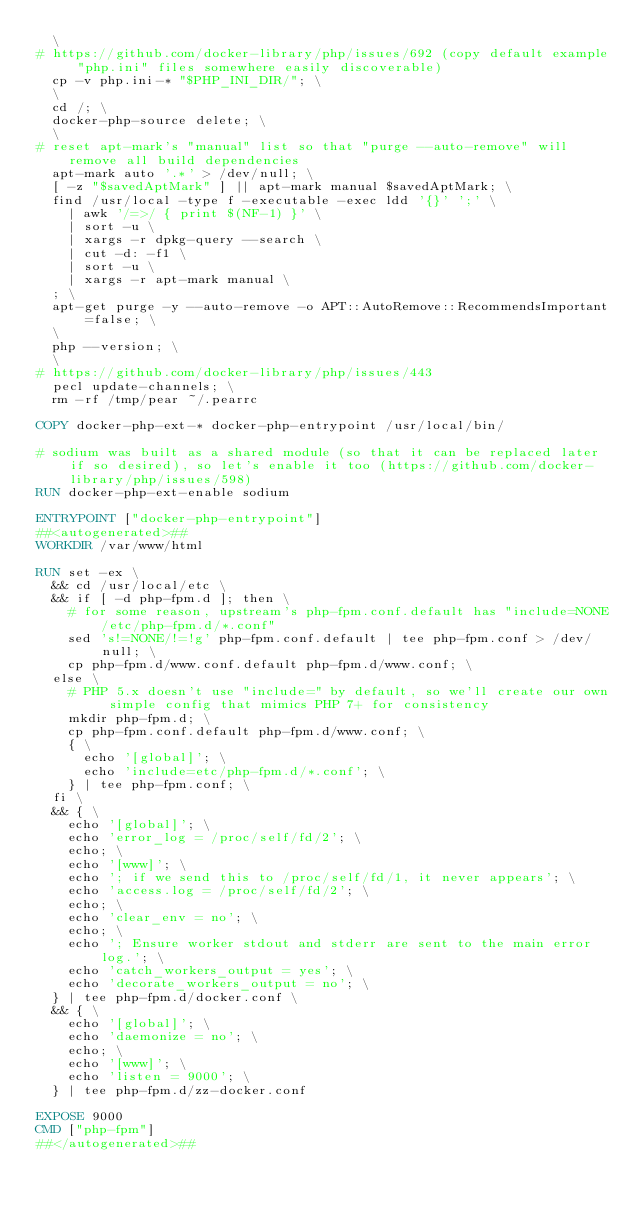Convert code to text. <code><loc_0><loc_0><loc_500><loc_500><_Dockerfile_>	\
# https://github.com/docker-library/php/issues/692 (copy default example "php.ini" files somewhere easily discoverable)
	cp -v php.ini-* "$PHP_INI_DIR/"; \
	\
	cd /; \
	docker-php-source delete; \
	\
# reset apt-mark's "manual" list so that "purge --auto-remove" will remove all build dependencies
	apt-mark auto '.*' > /dev/null; \
	[ -z "$savedAptMark" ] || apt-mark manual $savedAptMark; \
	find /usr/local -type f -executable -exec ldd '{}' ';' \
		| awk '/=>/ { print $(NF-1) }' \
		| sort -u \
		| xargs -r dpkg-query --search \
		| cut -d: -f1 \
		| sort -u \
		| xargs -r apt-mark manual \
	; \
	apt-get purge -y --auto-remove -o APT::AutoRemove::RecommendsImportant=false; \
	\
	php --version; \
	\
# https://github.com/docker-library/php/issues/443
	pecl update-channels; \
	rm -rf /tmp/pear ~/.pearrc

COPY docker-php-ext-* docker-php-entrypoint /usr/local/bin/

# sodium was built as a shared module (so that it can be replaced later if so desired), so let's enable it too (https://github.com/docker-library/php/issues/598)
RUN docker-php-ext-enable sodium

ENTRYPOINT ["docker-php-entrypoint"]
##<autogenerated>##
WORKDIR /var/www/html

RUN set -ex \
	&& cd /usr/local/etc \
	&& if [ -d php-fpm.d ]; then \
		# for some reason, upstream's php-fpm.conf.default has "include=NONE/etc/php-fpm.d/*.conf"
		sed 's!=NONE/!=!g' php-fpm.conf.default | tee php-fpm.conf > /dev/null; \
		cp php-fpm.d/www.conf.default php-fpm.d/www.conf; \
	else \
		# PHP 5.x doesn't use "include=" by default, so we'll create our own simple config that mimics PHP 7+ for consistency
		mkdir php-fpm.d; \
		cp php-fpm.conf.default php-fpm.d/www.conf; \
		{ \
			echo '[global]'; \
			echo 'include=etc/php-fpm.d/*.conf'; \
		} | tee php-fpm.conf; \
	fi \
	&& { \
		echo '[global]'; \
		echo 'error_log = /proc/self/fd/2'; \
		echo; \
		echo '[www]'; \
		echo '; if we send this to /proc/self/fd/1, it never appears'; \
		echo 'access.log = /proc/self/fd/2'; \
		echo; \
		echo 'clear_env = no'; \
		echo; \
		echo '; Ensure worker stdout and stderr are sent to the main error log.'; \
		echo 'catch_workers_output = yes'; \
		echo 'decorate_workers_output = no'; \
	} | tee php-fpm.d/docker.conf \
	&& { \
		echo '[global]'; \
		echo 'daemonize = no'; \
		echo; \
		echo '[www]'; \
		echo 'listen = 9000'; \
	} | tee php-fpm.d/zz-docker.conf

EXPOSE 9000
CMD ["php-fpm"]
##</autogenerated>##
</code> 